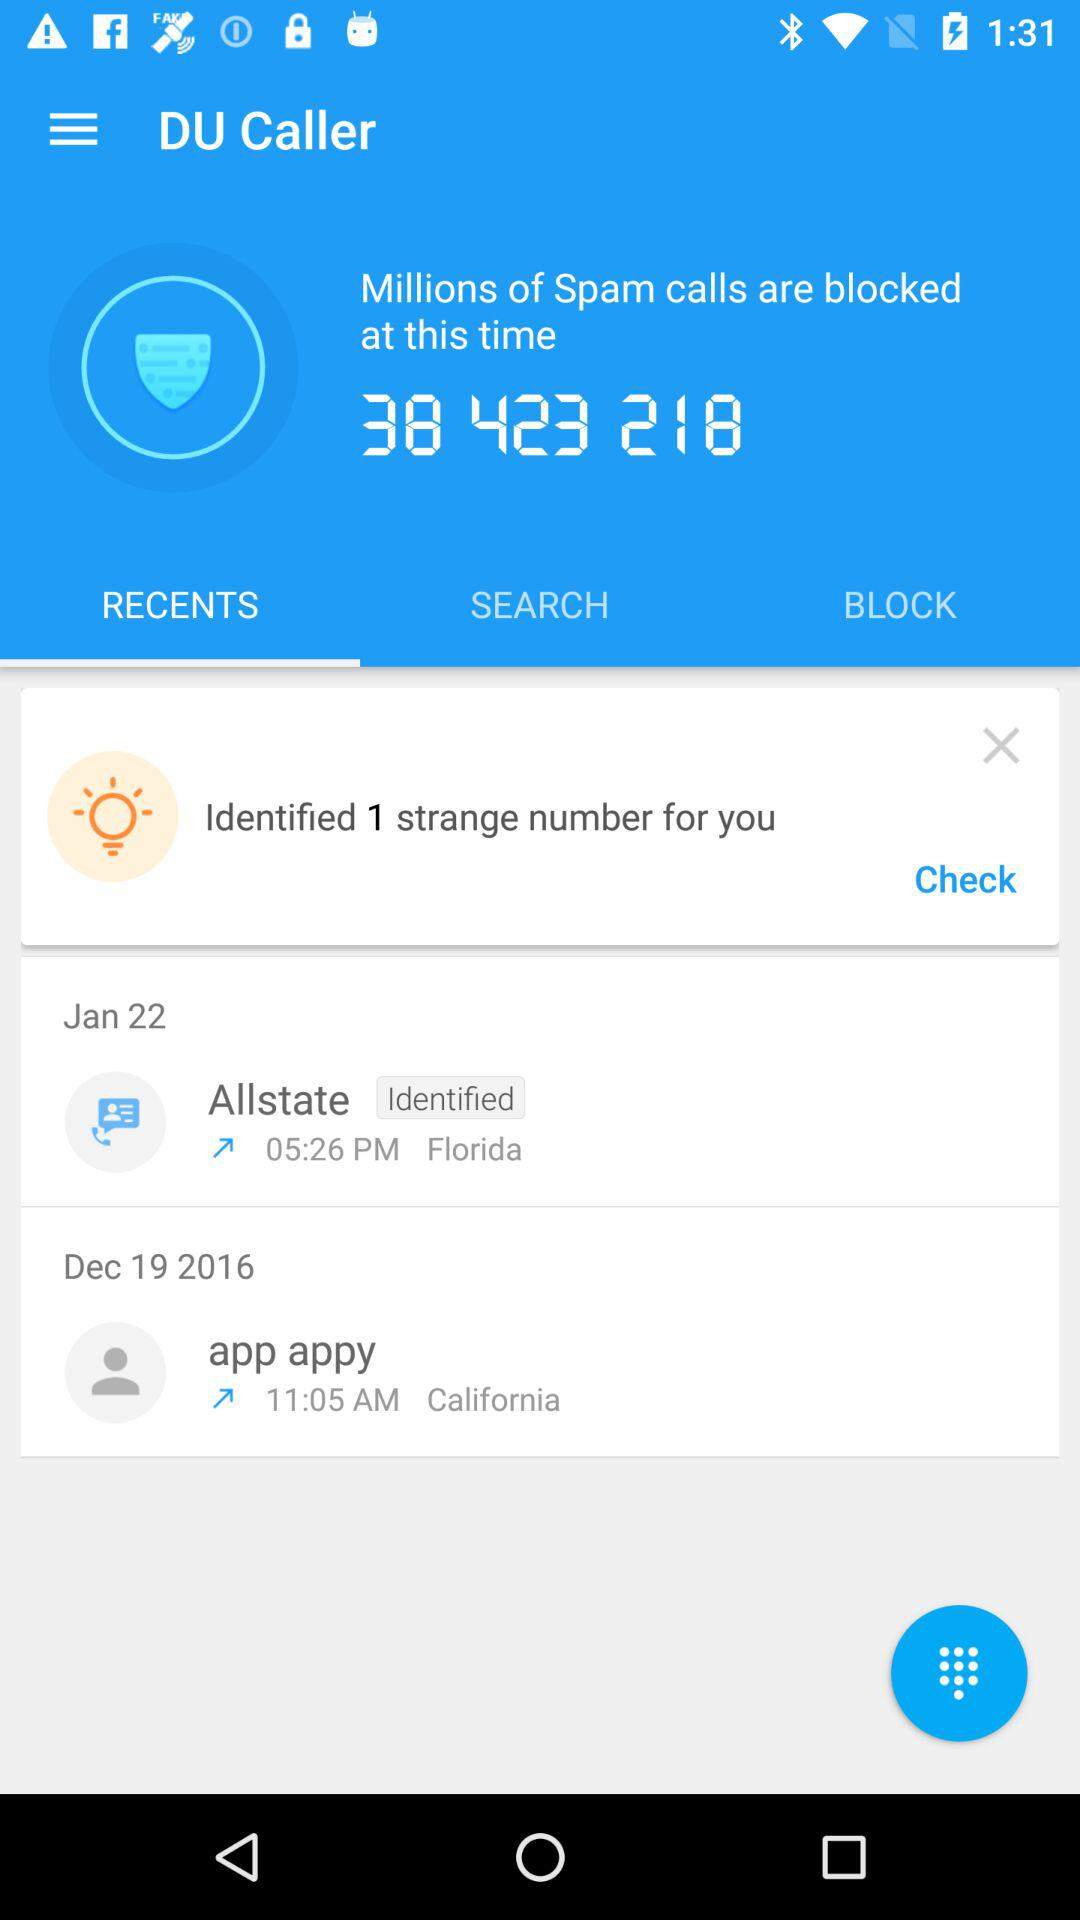Which tab is selected? The selected tab is "RECENTS". 